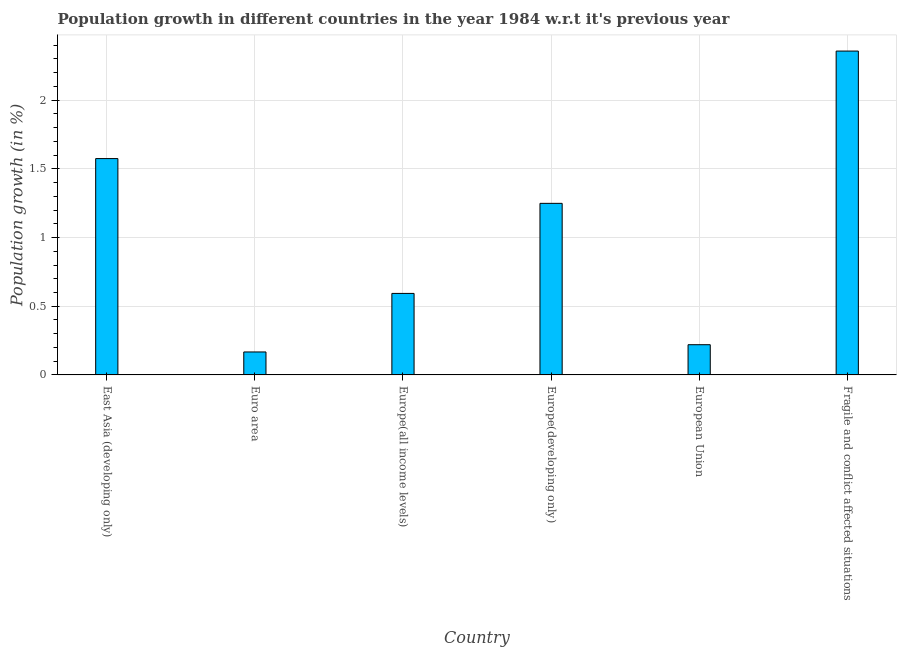What is the title of the graph?
Your answer should be compact. Population growth in different countries in the year 1984 w.r.t it's previous year. What is the label or title of the Y-axis?
Offer a very short reply. Population growth (in %). What is the population growth in European Union?
Your answer should be very brief. 0.22. Across all countries, what is the maximum population growth?
Provide a short and direct response. 2.36. Across all countries, what is the minimum population growth?
Your response must be concise. 0.17. In which country was the population growth maximum?
Make the answer very short. Fragile and conflict affected situations. What is the sum of the population growth?
Keep it short and to the point. 6.16. What is the difference between the population growth in Europe(all income levels) and European Union?
Your response must be concise. 0.37. What is the median population growth?
Offer a very short reply. 0.92. In how many countries, is the population growth greater than 1.5 %?
Your answer should be compact. 2. What is the ratio of the population growth in East Asia (developing only) to that in Europe(all income levels)?
Provide a succinct answer. 2.65. Is the population growth in European Union less than that in Fragile and conflict affected situations?
Keep it short and to the point. Yes. What is the difference between the highest and the second highest population growth?
Provide a short and direct response. 0.78. Is the sum of the population growth in East Asia (developing only) and European Union greater than the maximum population growth across all countries?
Your answer should be compact. No. What is the difference between the highest and the lowest population growth?
Give a very brief answer. 2.19. Are all the bars in the graph horizontal?
Give a very brief answer. No. Are the values on the major ticks of Y-axis written in scientific E-notation?
Offer a terse response. No. What is the Population growth (in %) in East Asia (developing only)?
Provide a succinct answer. 1.57. What is the Population growth (in %) of Euro area?
Offer a terse response. 0.17. What is the Population growth (in %) of Europe(all income levels)?
Your response must be concise. 0.59. What is the Population growth (in %) of Europe(developing only)?
Provide a short and direct response. 1.25. What is the Population growth (in %) of European Union?
Ensure brevity in your answer.  0.22. What is the Population growth (in %) of Fragile and conflict affected situations?
Your answer should be compact. 2.36. What is the difference between the Population growth (in %) in East Asia (developing only) and Euro area?
Provide a succinct answer. 1.41. What is the difference between the Population growth (in %) in East Asia (developing only) and Europe(all income levels)?
Keep it short and to the point. 0.98. What is the difference between the Population growth (in %) in East Asia (developing only) and Europe(developing only)?
Provide a short and direct response. 0.33. What is the difference between the Population growth (in %) in East Asia (developing only) and European Union?
Provide a succinct answer. 1.35. What is the difference between the Population growth (in %) in East Asia (developing only) and Fragile and conflict affected situations?
Your response must be concise. -0.78. What is the difference between the Population growth (in %) in Euro area and Europe(all income levels)?
Your answer should be compact. -0.43. What is the difference between the Population growth (in %) in Euro area and Europe(developing only)?
Give a very brief answer. -1.08. What is the difference between the Population growth (in %) in Euro area and European Union?
Provide a short and direct response. -0.05. What is the difference between the Population growth (in %) in Euro area and Fragile and conflict affected situations?
Keep it short and to the point. -2.19. What is the difference between the Population growth (in %) in Europe(all income levels) and Europe(developing only)?
Your answer should be very brief. -0.66. What is the difference between the Population growth (in %) in Europe(all income levels) and European Union?
Ensure brevity in your answer.  0.37. What is the difference between the Population growth (in %) in Europe(all income levels) and Fragile and conflict affected situations?
Offer a terse response. -1.76. What is the difference between the Population growth (in %) in Europe(developing only) and European Union?
Your answer should be compact. 1.03. What is the difference between the Population growth (in %) in Europe(developing only) and Fragile and conflict affected situations?
Your answer should be compact. -1.11. What is the difference between the Population growth (in %) in European Union and Fragile and conflict affected situations?
Keep it short and to the point. -2.14. What is the ratio of the Population growth (in %) in East Asia (developing only) to that in Euro area?
Ensure brevity in your answer.  9.42. What is the ratio of the Population growth (in %) in East Asia (developing only) to that in Europe(all income levels)?
Your response must be concise. 2.65. What is the ratio of the Population growth (in %) in East Asia (developing only) to that in Europe(developing only)?
Keep it short and to the point. 1.26. What is the ratio of the Population growth (in %) in East Asia (developing only) to that in European Union?
Offer a terse response. 7.16. What is the ratio of the Population growth (in %) in East Asia (developing only) to that in Fragile and conflict affected situations?
Provide a short and direct response. 0.67. What is the ratio of the Population growth (in %) in Euro area to that in Europe(all income levels)?
Offer a terse response. 0.28. What is the ratio of the Population growth (in %) in Euro area to that in Europe(developing only)?
Ensure brevity in your answer.  0.13. What is the ratio of the Population growth (in %) in Euro area to that in European Union?
Give a very brief answer. 0.76. What is the ratio of the Population growth (in %) in Euro area to that in Fragile and conflict affected situations?
Make the answer very short. 0.07. What is the ratio of the Population growth (in %) in Europe(all income levels) to that in Europe(developing only)?
Offer a terse response. 0.47. What is the ratio of the Population growth (in %) in Europe(all income levels) to that in European Union?
Your answer should be very brief. 2.7. What is the ratio of the Population growth (in %) in Europe(all income levels) to that in Fragile and conflict affected situations?
Your answer should be compact. 0.25. What is the ratio of the Population growth (in %) in Europe(developing only) to that in European Union?
Make the answer very short. 5.68. What is the ratio of the Population growth (in %) in Europe(developing only) to that in Fragile and conflict affected situations?
Ensure brevity in your answer.  0.53. What is the ratio of the Population growth (in %) in European Union to that in Fragile and conflict affected situations?
Your response must be concise. 0.09. 